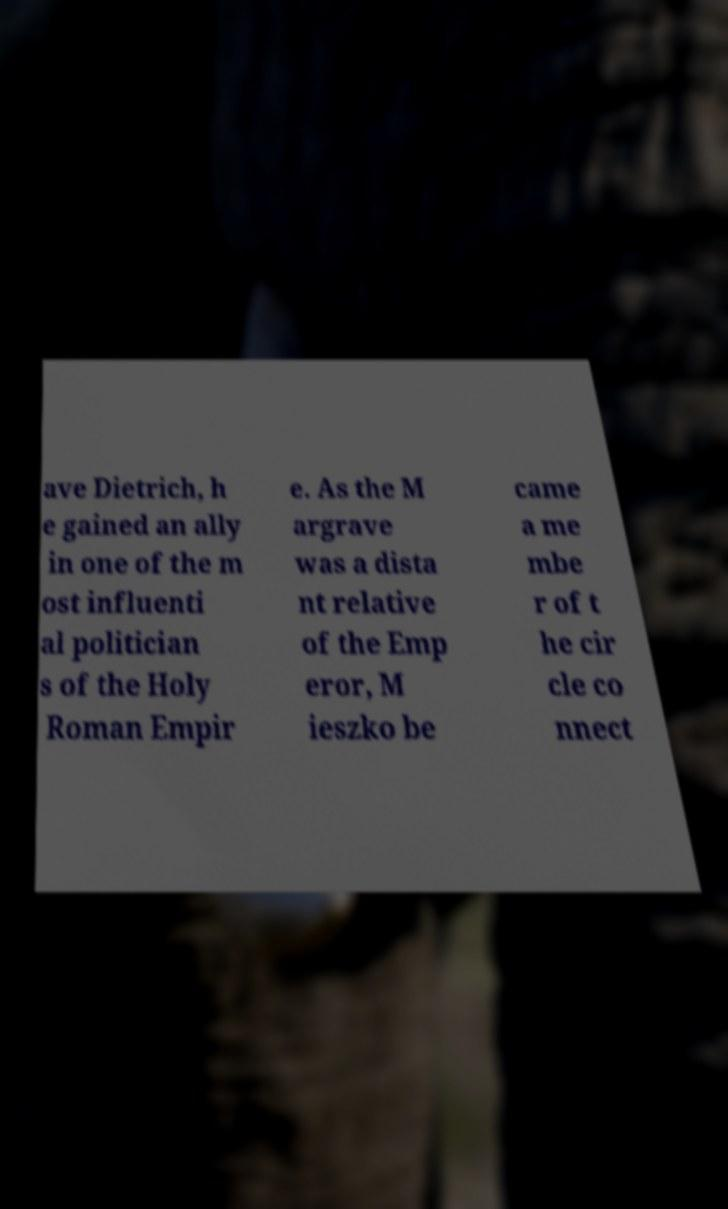For documentation purposes, I need the text within this image transcribed. Could you provide that? ave Dietrich, h e gained an ally in one of the m ost influenti al politician s of the Holy Roman Empir e. As the M argrave was a dista nt relative of the Emp eror, M ieszko be came a me mbe r of t he cir cle co nnect 